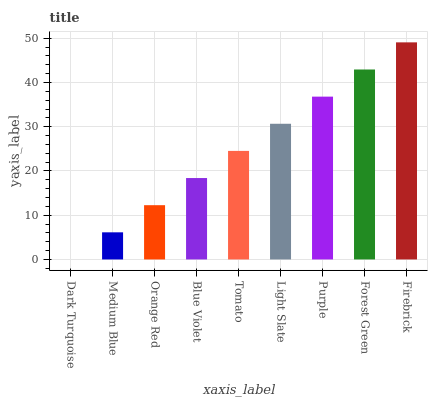Is Dark Turquoise the minimum?
Answer yes or no. Yes. Is Firebrick the maximum?
Answer yes or no. Yes. Is Medium Blue the minimum?
Answer yes or no. No. Is Medium Blue the maximum?
Answer yes or no. No. Is Medium Blue greater than Dark Turquoise?
Answer yes or no. Yes. Is Dark Turquoise less than Medium Blue?
Answer yes or no. Yes. Is Dark Turquoise greater than Medium Blue?
Answer yes or no. No. Is Medium Blue less than Dark Turquoise?
Answer yes or no. No. Is Tomato the high median?
Answer yes or no. Yes. Is Tomato the low median?
Answer yes or no. Yes. Is Firebrick the high median?
Answer yes or no. No. Is Firebrick the low median?
Answer yes or no. No. 